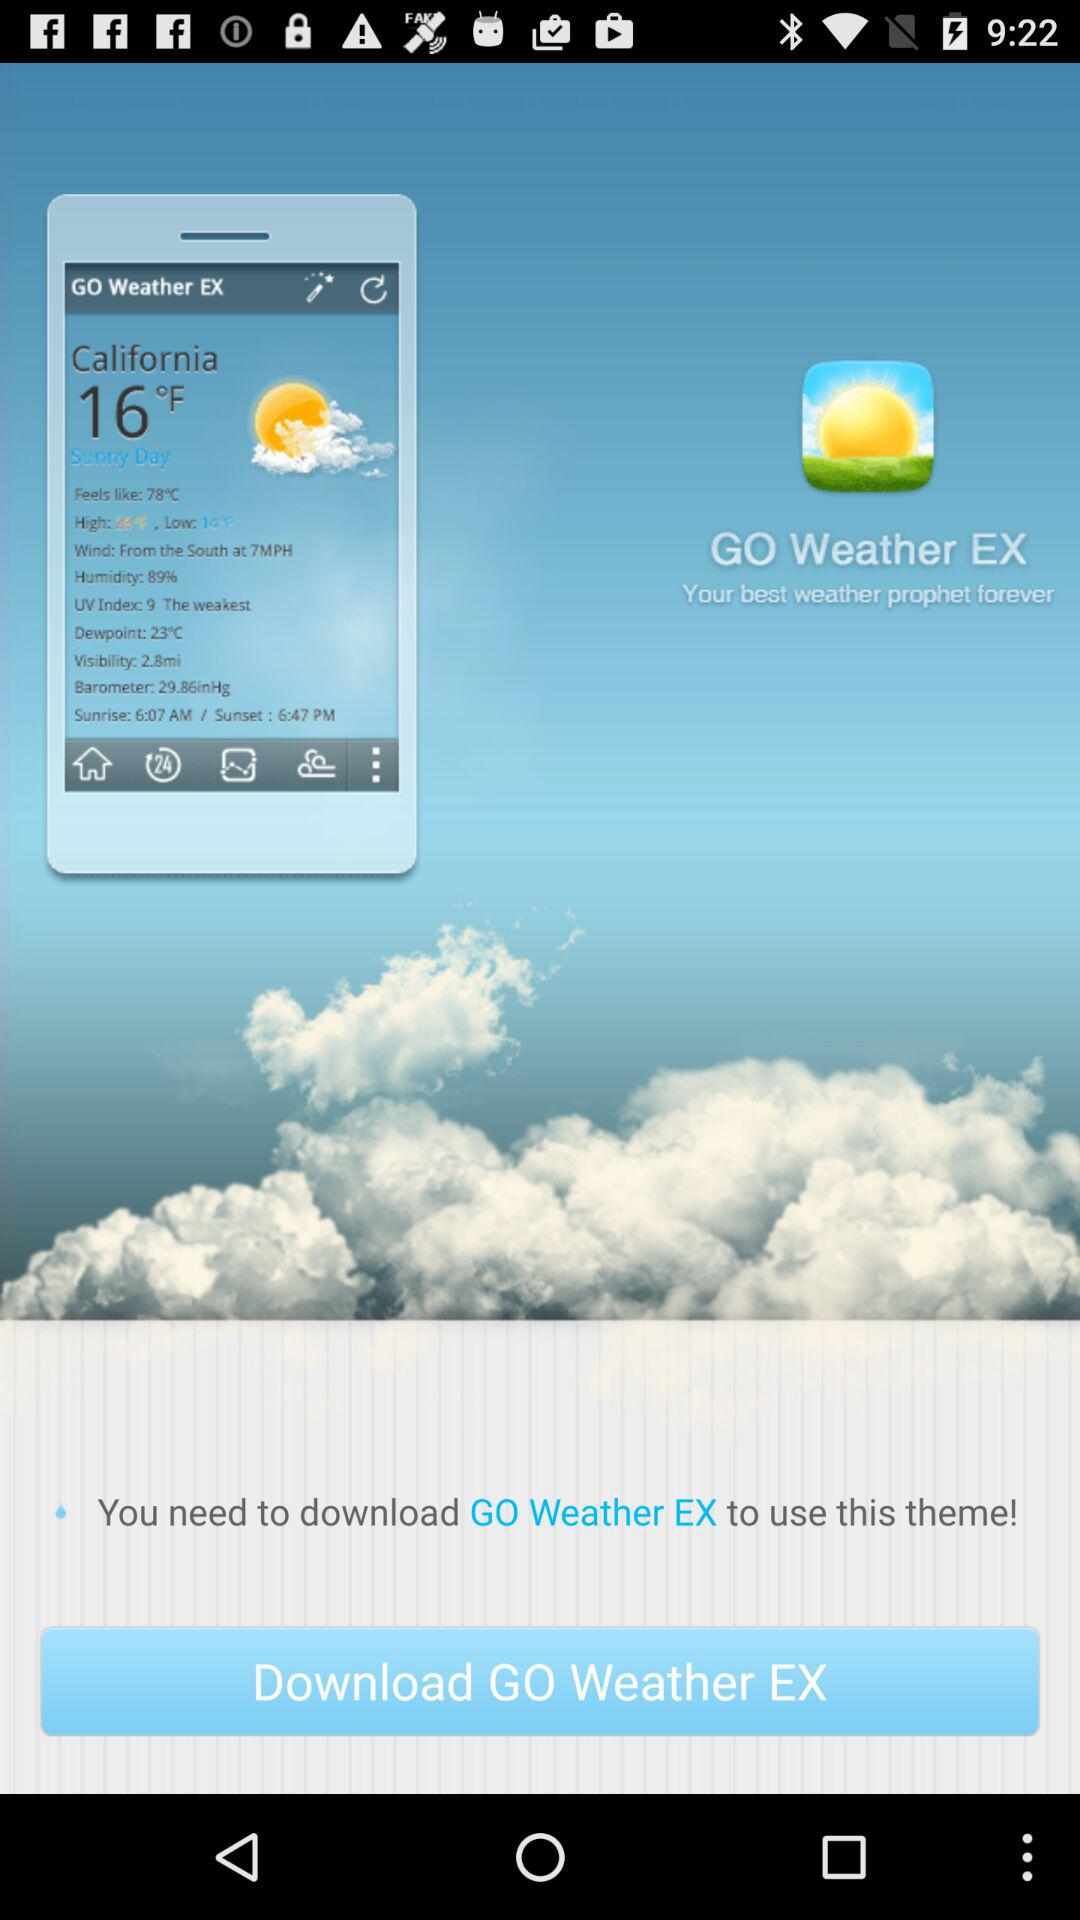What is the humidity in California? The humidity in California is 89%. 